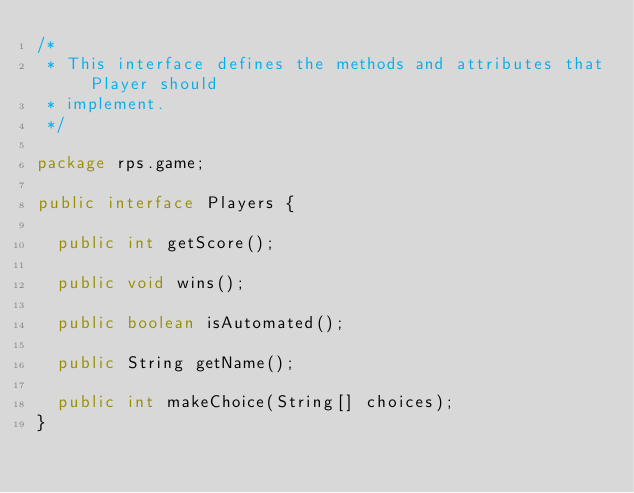Convert code to text. <code><loc_0><loc_0><loc_500><loc_500><_Java_>/* 
 * This interface defines the methods and attributes that Player should
 * implement.
 */

package rps.game;

public interface Players {

	public int getScore();

	public void wins();
	
	public boolean isAutomated();
	
	public String getName();

	public int makeChoice(String[] choices);
}
</code> 